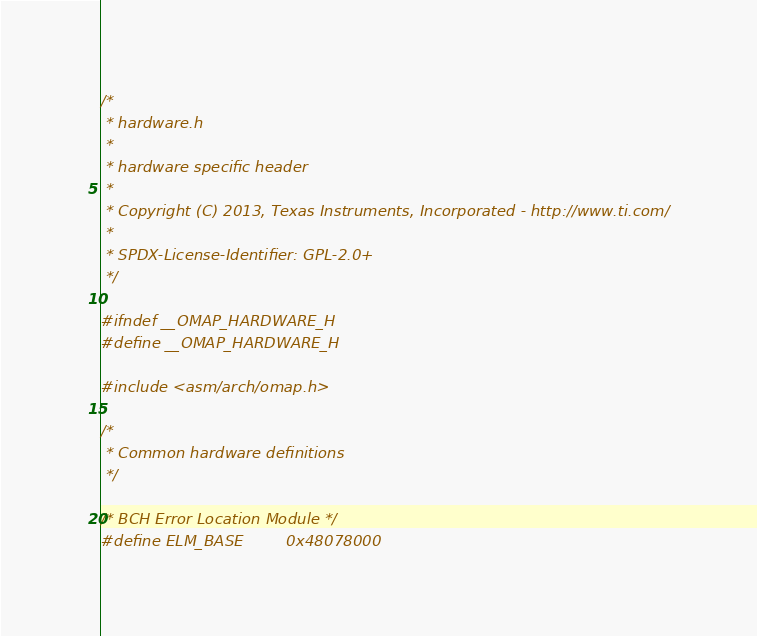Convert code to text. <code><loc_0><loc_0><loc_500><loc_500><_C_>/*
 * hardware.h
 *
 * hardware specific header
 *
 * Copyright (C) 2013, Texas Instruments, Incorporated - http://www.ti.com/
 *
 * SPDX-License-Identifier:	GPL-2.0+
 */

#ifndef __OMAP_HARDWARE_H
#define __OMAP_HARDWARE_H

#include <asm/arch/omap.h>

/*
 * Common hardware definitions
 */

/* BCH Error Location Module */
#define ELM_BASE			0x48078000
</code> 